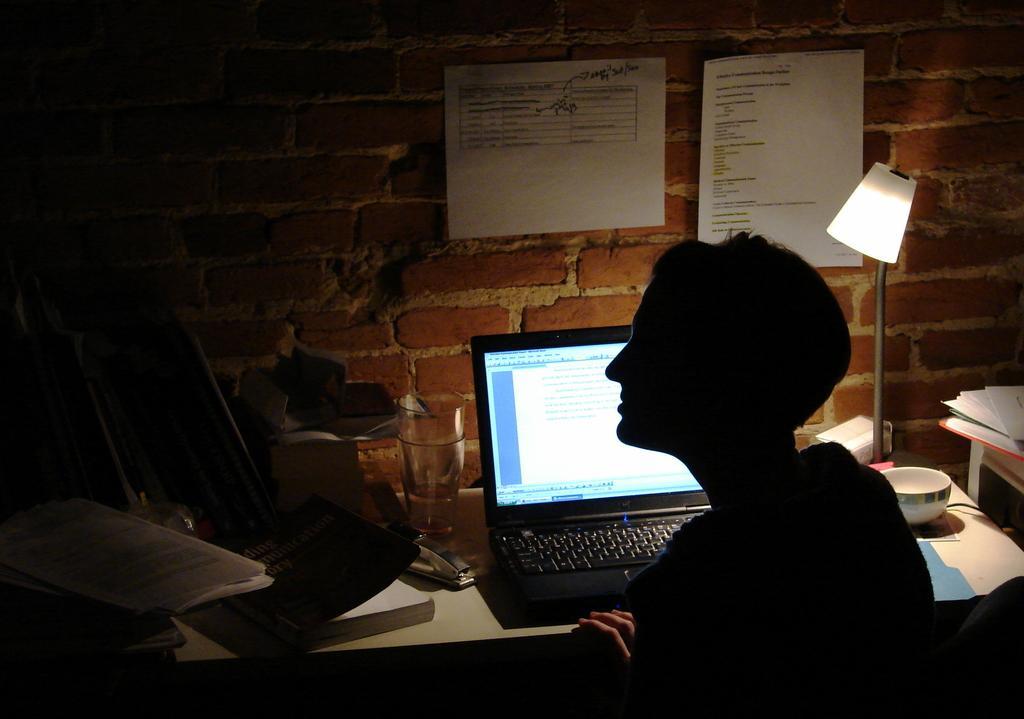Describe this image in one or two sentences. As we can see in the image there is a brick wall, papers, a person sitting on chair and a table. On table there are papers,lamp, bowl, laptop and book. 